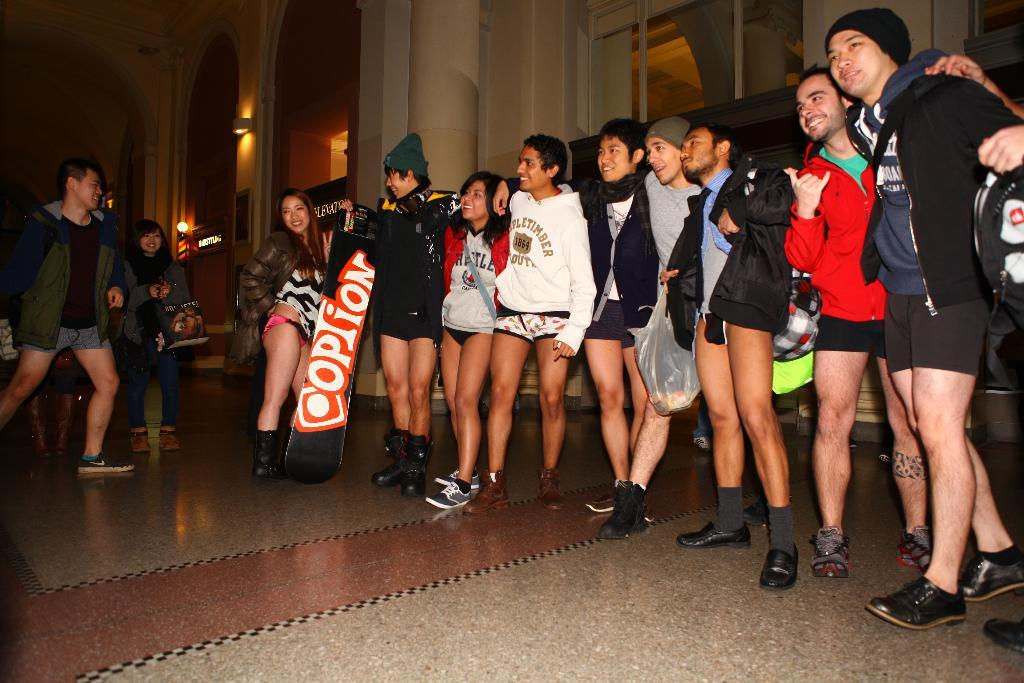<image>
Offer a succinct explanation of the picture presented. People have their arms around each other and one has a snowboard with the word option on it. 